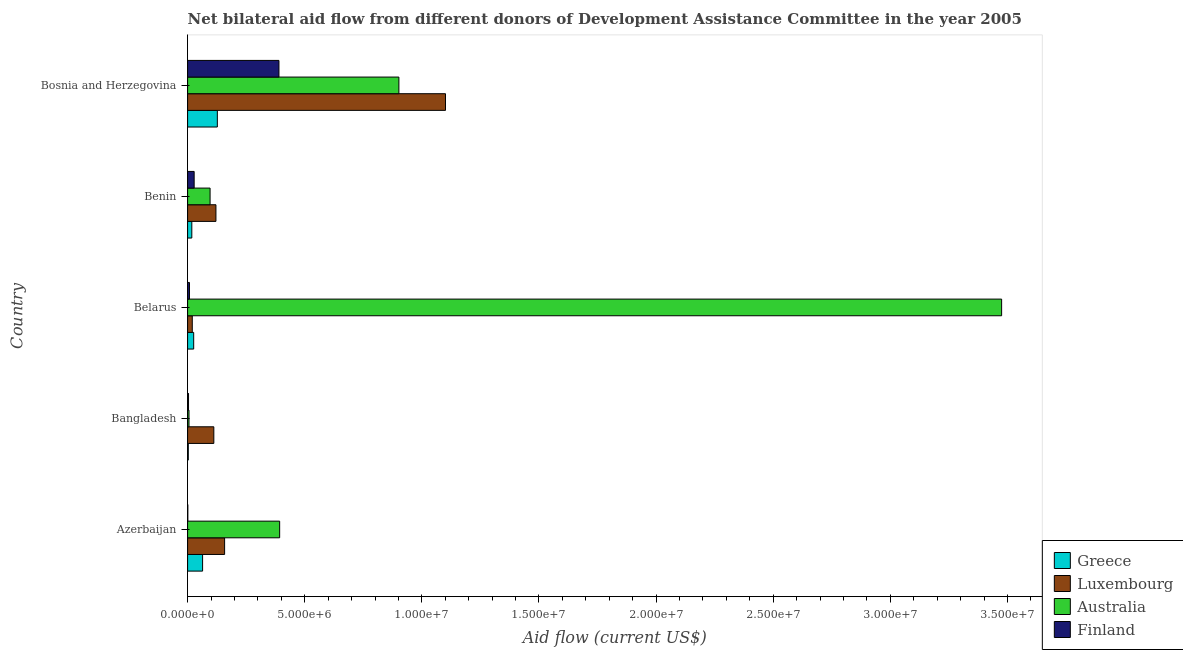How many different coloured bars are there?
Offer a very short reply. 4. How many bars are there on the 4th tick from the top?
Ensure brevity in your answer.  4. How many bars are there on the 1st tick from the bottom?
Your response must be concise. 4. What is the label of the 3rd group of bars from the top?
Ensure brevity in your answer.  Belarus. In how many cases, is the number of bars for a given country not equal to the number of legend labels?
Keep it short and to the point. 0. What is the amount of aid given by luxembourg in Bangladesh?
Ensure brevity in your answer.  1.12e+06. Across all countries, what is the maximum amount of aid given by luxembourg?
Your response must be concise. 1.10e+07. Across all countries, what is the minimum amount of aid given by finland?
Keep it short and to the point. 10000. In which country was the amount of aid given by greece maximum?
Ensure brevity in your answer.  Bosnia and Herzegovina. What is the total amount of aid given by greece in the graph?
Make the answer very short. 2.38e+06. What is the difference between the amount of aid given by luxembourg in Azerbaijan and that in Belarus?
Offer a very short reply. 1.38e+06. What is the difference between the amount of aid given by greece in Bosnia and Herzegovina and the amount of aid given by finland in Azerbaijan?
Offer a terse response. 1.26e+06. What is the average amount of aid given by australia per country?
Provide a short and direct response. 9.74e+06. What is the difference between the amount of aid given by luxembourg and amount of aid given by greece in Benin?
Provide a short and direct response. 1.03e+06. In how many countries, is the amount of aid given by australia greater than 9000000 US$?
Offer a very short reply. 2. What is the ratio of the amount of aid given by luxembourg in Azerbaijan to that in Bosnia and Herzegovina?
Provide a short and direct response. 0.14. Is the difference between the amount of aid given by luxembourg in Azerbaijan and Belarus greater than the difference between the amount of aid given by greece in Azerbaijan and Belarus?
Provide a succinct answer. Yes. What is the difference between the highest and the second highest amount of aid given by australia?
Ensure brevity in your answer.  2.57e+07. What is the difference between the highest and the lowest amount of aid given by finland?
Your answer should be compact. 3.89e+06. In how many countries, is the amount of aid given by finland greater than the average amount of aid given by finland taken over all countries?
Ensure brevity in your answer.  1. Is the sum of the amount of aid given by greece in Belarus and Benin greater than the maximum amount of aid given by luxembourg across all countries?
Your answer should be very brief. No. What does the 2nd bar from the top in Azerbaijan represents?
Make the answer very short. Australia. What does the 3rd bar from the bottom in Bosnia and Herzegovina represents?
Your answer should be very brief. Australia. Is it the case that in every country, the sum of the amount of aid given by greece and amount of aid given by luxembourg is greater than the amount of aid given by australia?
Keep it short and to the point. No. How many bars are there?
Offer a terse response. 20. Are all the bars in the graph horizontal?
Offer a terse response. Yes. Are the values on the major ticks of X-axis written in scientific E-notation?
Give a very brief answer. Yes. Does the graph contain any zero values?
Keep it short and to the point. No. Does the graph contain grids?
Keep it short and to the point. No. Where does the legend appear in the graph?
Your response must be concise. Bottom right. How are the legend labels stacked?
Keep it short and to the point. Vertical. What is the title of the graph?
Offer a very short reply. Net bilateral aid flow from different donors of Development Assistance Committee in the year 2005. What is the label or title of the Y-axis?
Provide a short and direct response. Country. What is the Aid flow (current US$) in Greece in Azerbaijan?
Offer a terse response. 6.40e+05. What is the Aid flow (current US$) of Luxembourg in Azerbaijan?
Your answer should be very brief. 1.58e+06. What is the Aid flow (current US$) of Australia in Azerbaijan?
Provide a succinct answer. 3.93e+06. What is the Aid flow (current US$) of Finland in Azerbaijan?
Keep it short and to the point. 10000. What is the Aid flow (current US$) of Greece in Bangladesh?
Give a very brief answer. 3.00e+04. What is the Aid flow (current US$) of Luxembourg in Bangladesh?
Provide a short and direct response. 1.12e+06. What is the Aid flow (current US$) in Australia in Bangladesh?
Make the answer very short. 6.00e+04. What is the Aid flow (current US$) in Finland in Bangladesh?
Keep it short and to the point. 4.00e+04. What is the Aid flow (current US$) of Greece in Belarus?
Offer a very short reply. 2.60e+05. What is the Aid flow (current US$) of Australia in Belarus?
Make the answer very short. 3.48e+07. What is the Aid flow (current US$) of Finland in Belarus?
Offer a terse response. 8.00e+04. What is the Aid flow (current US$) in Luxembourg in Benin?
Offer a very short reply. 1.21e+06. What is the Aid flow (current US$) of Australia in Benin?
Your answer should be very brief. 9.60e+05. What is the Aid flow (current US$) of Greece in Bosnia and Herzegovina?
Ensure brevity in your answer.  1.27e+06. What is the Aid flow (current US$) of Luxembourg in Bosnia and Herzegovina?
Keep it short and to the point. 1.10e+07. What is the Aid flow (current US$) of Australia in Bosnia and Herzegovina?
Give a very brief answer. 9.02e+06. What is the Aid flow (current US$) in Finland in Bosnia and Herzegovina?
Keep it short and to the point. 3.90e+06. Across all countries, what is the maximum Aid flow (current US$) in Greece?
Your response must be concise. 1.27e+06. Across all countries, what is the maximum Aid flow (current US$) of Luxembourg?
Your response must be concise. 1.10e+07. Across all countries, what is the maximum Aid flow (current US$) in Australia?
Your answer should be compact. 3.48e+07. Across all countries, what is the maximum Aid flow (current US$) in Finland?
Ensure brevity in your answer.  3.90e+06. Across all countries, what is the minimum Aid flow (current US$) in Greece?
Your answer should be very brief. 3.00e+04. Across all countries, what is the minimum Aid flow (current US$) in Australia?
Provide a succinct answer. 6.00e+04. Across all countries, what is the minimum Aid flow (current US$) in Finland?
Provide a short and direct response. 10000. What is the total Aid flow (current US$) of Greece in the graph?
Offer a terse response. 2.38e+06. What is the total Aid flow (current US$) in Luxembourg in the graph?
Provide a succinct answer. 1.51e+07. What is the total Aid flow (current US$) in Australia in the graph?
Provide a short and direct response. 4.87e+07. What is the total Aid flow (current US$) of Finland in the graph?
Provide a succinct answer. 4.31e+06. What is the difference between the Aid flow (current US$) of Greece in Azerbaijan and that in Bangladesh?
Give a very brief answer. 6.10e+05. What is the difference between the Aid flow (current US$) of Australia in Azerbaijan and that in Bangladesh?
Give a very brief answer. 3.87e+06. What is the difference between the Aid flow (current US$) in Greece in Azerbaijan and that in Belarus?
Offer a very short reply. 3.80e+05. What is the difference between the Aid flow (current US$) in Luxembourg in Azerbaijan and that in Belarus?
Provide a short and direct response. 1.38e+06. What is the difference between the Aid flow (current US$) of Australia in Azerbaijan and that in Belarus?
Your answer should be compact. -3.08e+07. What is the difference between the Aid flow (current US$) in Finland in Azerbaijan and that in Belarus?
Offer a very short reply. -7.00e+04. What is the difference between the Aid flow (current US$) in Greece in Azerbaijan and that in Benin?
Make the answer very short. 4.60e+05. What is the difference between the Aid flow (current US$) in Luxembourg in Azerbaijan and that in Benin?
Offer a very short reply. 3.70e+05. What is the difference between the Aid flow (current US$) of Australia in Azerbaijan and that in Benin?
Your answer should be compact. 2.97e+06. What is the difference between the Aid flow (current US$) of Greece in Azerbaijan and that in Bosnia and Herzegovina?
Provide a short and direct response. -6.30e+05. What is the difference between the Aid flow (current US$) of Luxembourg in Azerbaijan and that in Bosnia and Herzegovina?
Your response must be concise. -9.43e+06. What is the difference between the Aid flow (current US$) in Australia in Azerbaijan and that in Bosnia and Herzegovina?
Provide a succinct answer. -5.09e+06. What is the difference between the Aid flow (current US$) of Finland in Azerbaijan and that in Bosnia and Herzegovina?
Provide a succinct answer. -3.89e+06. What is the difference between the Aid flow (current US$) in Greece in Bangladesh and that in Belarus?
Your response must be concise. -2.30e+05. What is the difference between the Aid flow (current US$) in Luxembourg in Bangladesh and that in Belarus?
Give a very brief answer. 9.20e+05. What is the difference between the Aid flow (current US$) in Australia in Bangladesh and that in Belarus?
Your response must be concise. -3.47e+07. What is the difference between the Aid flow (current US$) in Greece in Bangladesh and that in Benin?
Your answer should be very brief. -1.50e+05. What is the difference between the Aid flow (current US$) of Australia in Bangladesh and that in Benin?
Provide a short and direct response. -9.00e+05. What is the difference between the Aid flow (current US$) of Finland in Bangladesh and that in Benin?
Your answer should be very brief. -2.40e+05. What is the difference between the Aid flow (current US$) in Greece in Bangladesh and that in Bosnia and Herzegovina?
Offer a very short reply. -1.24e+06. What is the difference between the Aid flow (current US$) of Luxembourg in Bangladesh and that in Bosnia and Herzegovina?
Offer a terse response. -9.89e+06. What is the difference between the Aid flow (current US$) in Australia in Bangladesh and that in Bosnia and Herzegovina?
Provide a short and direct response. -8.96e+06. What is the difference between the Aid flow (current US$) in Finland in Bangladesh and that in Bosnia and Herzegovina?
Your answer should be very brief. -3.86e+06. What is the difference between the Aid flow (current US$) of Greece in Belarus and that in Benin?
Your response must be concise. 8.00e+04. What is the difference between the Aid flow (current US$) in Luxembourg in Belarus and that in Benin?
Your response must be concise. -1.01e+06. What is the difference between the Aid flow (current US$) in Australia in Belarus and that in Benin?
Offer a terse response. 3.38e+07. What is the difference between the Aid flow (current US$) in Greece in Belarus and that in Bosnia and Herzegovina?
Provide a succinct answer. -1.01e+06. What is the difference between the Aid flow (current US$) of Luxembourg in Belarus and that in Bosnia and Herzegovina?
Provide a short and direct response. -1.08e+07. What is the difference between the Aid flow (current US$) in Australia in Belarus and that in Bosnia and Herzegovina?
Your answer should be very brief. 2.57e+07. What is the difference between the Aid flow (current US$) of Finland in Belarus and that in Bosnia and Herzegovina?
Your answer should be compact. -3.82e+06. What is the difference between the Aid flow (current US$) in Greece in Benin and that in Bosnia and Herzegovina?
Keep it short and to the point. -1.09e+06. What is the difference between the Aid flow (current US$) of Luxembourg in Benin and that in Bosnia and Herzegovina?
Your answer should be very brief. -9.80e+06. What is the difference between the Aid flow (current US$) in Australia in Benin and that in Bosnia and Herzegovina?
Offer a terse response. -8.06e+06. What is the difference between the Aid flow (current US$) of Finland in Benin and that in Bosnia and Herzegovina?
Offer a terse response. -3.62e+06. What is the difference between the Aid flow (current US$) in Greece in Azerbaijan and the Aid flow (current US$) in Luxembourg in Bangladesh?
Offer a terse response. -4.80e+05. What is the difference between the Aid flow (current US$) of Greece in Azerbaijan and the Aid flow (current US$) of Australia in Bangladesh?
Your response must be concise. 5.80e+05. What is the difference between the Aid flow (current US$) in Luxembourg in Azerbaijan and the Aid flow (current US$) in Australia in Bangladesh?
Your answer should be very brief. 1.52e+06. What is the difference between the Aid flow (current US$) in Luxembourg in Azerbaijan and the Aid flow (current US$) in Finland in Bangladesh?
Keep it short and to the point. 1.54e+06. What is the difference between the Aid flow (current US$) in Australia in Azerbaijan and the Aid flow (current US$) in Finland in Bangladesh?
Offer a very short reply. 3.89e+06. What is the difference between the Aid flow (current US$) of Greece in Azerbaijan and the Aid flow (current US$) of Luxembourg in Belarus?
Keep it short and to the point. 4.40e+05. What is the difference between the Aid flow (current US$) of Greece in Azerbaijan and the Aid flow (current US$) of Australia in Belarus?
Offer a terse response. -3.41e+07. What is the difference between the Aid flow (current US$) in Greece in Azerbaijan and the Aid flow (current US$) in Finland in Belarus?
Your answer should be compact. 5.60e+05. What is the difference between the Aid flow (current US$) of Luxembourg in Azerbaijan and the Aid flow (current US$) of Australia in Belarus?
Give a very brief answer. -3.32e+07. What is the difference between the Aid flow (current US$) of Luxembourg in Azerbaijan and the Aid flow (current US$) of Finland in Belarus?
Offer a very short reply. 1.50e+06. What is the difference between the Aid flow (current US$) in Australia in Azerbaijan and the Aid flow (current US$) in Finland in Belarus?
Give a very brief answer. 3.85e+06. What is the difference between the Aid flow (current US$) in Greece in Azerbaijan and the Aid flow (current US$) in Luxembourg in Benin?
Provide a succinct answer. -5.70e+05. What is the difference between the Aid flow (current US$) in Greece in Azerbaijan and the Aid flow (current US$) in Australia in Benin?
Your response must be concise. -3.20e+05. What is the difference between the Aid flow (current US$) in Greece in Azerbaijan and the Aid flow (current US$) in Finland in Benin?
Provide a short and direct response. 3.60e+05. What is the difference between the Aid flow (current US$) of Luxembourg in Azerbaijan and the Aid flow (current US$) of Australia in Benin?
Offer a terse response. 6.20e+05. What is the difference between the Aid flow (current US$) of Luxembourg in Azerbaijan and the Aid flow (current US$) of Finland in Benin?
Make the answer very short. 1.30e+06. What is the difference between the Aid flow (current US$) of Australia in Azerbaijan and the Aid flow (current US$) of Finland in Benin?
Give a very brief answer. 3.65e+06. What is the difference between the Aid flow (current US$) in Greece in Azerbaijan and the Aid flow (current US$) in Luxembourg in Bosnia and Herzegovina?
Provide a succinct answer. -1.04e+07. What is the difference between the Aid flow (current US$) in Greece in Azerbaijan and the Aid flow (current US$) in Australia in Bosnia and Herzegovina?
Your answer should be very brief. -8.38e+06. What is the difference between the Aid flow (current US$) of Greece in Azerbaijan and the Aid flow (current US$) of Finland in Bosnia and Herzegovina?
Your response must be concise. -3.26e+06. What is the difference between the Aid flow (current US$) in Luxembourg in Azerbaijan and the Aid flow (current US$) in Australia in Bosnia and Herzegovina?
Give a very brief answer. -7.44e+06. What is the difference between the Aid flow (current US$) of Luxembourg in Azerbaijan and the Aid flow (current US$) of Finland in Bosnia and Herzegovina?
Ensure brevity in your answer.  -2.32e+06. What is the difference between the Aid flow (current US$) in Australia in Azerbaijan and the Aid flow (current US$) in Finland in Bosnia and Herzegovina?
Make the answer very short. 3.00e+04. What is the difference between the Aid flow (current US$) in Greece in Bangladesh and the Aid flow (current US$) in Australia in Belarus?
Ensure brevity in your answer.  -3.47e+07. What is the difference between the Aid flow (current US$) of Luxembourg in Bangladesh and the Aid flow (current US$) of Australia in Belarus?
Provide a short and direct response. -3.36e+07. What is the difference between the Aid flow (current US$) in Luxembourg in Bangladesh and the Aid flow (current US$) in Finland in Belarus?
Give a very brief answer. 1.04e+06. What is the difference between the Aid flow (current US$) in Greece in Bangladesh and the Aid flow (current US$) in Luxembourg in Benin?
Offer a very short reply. -1.18e+06. What is the difference between the Aid flow (current US$) in Greece in Bangladesh and the Aid flow (current US$) in Australia in Benin?
Provide a succinct answer. -9.30e+05. What is the difference between the Aid flow (current US$) of Luxembourg in Bangladesh and the Aid flow (current US$) of Australia in Benin?
Give a very brief answer. 1.60e+05. What is the difference between the Aid flow (current US$) in Luxembourg in Bangladesh and the Aid flow (current US$) in Finland in Benin?
Provide a short and direct response. 8.40e+05. What is the difference between the Aid flow (current US$) in Australia in Bangladesh and the Aid flow (current US$) in Finland in Benin?
Your answer should be very brief. -2.20e+05. What is the difference between the Aid flow (current US$) in Greece in Bangladesh and the Aid flow (current US$) in Luxembourg in Bosnia and Herzegovina?
Make the answer very short. -1.10e+07. What is the difference between the Aid flow (current US$) of Greece in Bangladesh and the Aid flow (current US$) of Australia in Bosnia and Herzegovina?
Ensure brevity in your answer.  -8.99e+06. What is the difference between the Aid flow (current US$) in Greece in Bangladesh and the Aid flow (current US$) in Finland in Bosnia and Herzegovina?
Offer a very short reply. -3.87e+06. What is the difference between the Aid flow (current US$) of Luxembourg in Bangladesh and the Aid flow (current US$) of Australia in Bosnia and Herzegovina?
Keep it short and to the point. -7.90e+06. What is the difference between the Aid flow (current US$) of Luxembourg in Bangladesh and the Aid flow (current US$) of Finland in Bosnia and Herzegovina?
Ensure brevity in your answer.  -2.78e+06. What is the difference between the Aid flow (current US$) in Australia in Bangladesh and the Aid flow (current US$) in Finland in Bosnia and Herzegovina?
Ensure brevity in your answer.  -3.84e+06. What is the difference between the Aid flow (current US$) of Greece in Belarus and the Aid flow (current US$) of Luxembourg in Benin?
Offer a terse response. -9.50e+05. What is the difference between the Aid flow (current US$) in Greece in Belarus and the Aid flow (current US$) in Australia in Benin?
Keep it short and to the point. -7.00e+05. What is the difference between the Aid flow (current US$) of Greece in Belarus and the Aid flow (current US$) of Finland in Benin?
Offer a very short reply. -2.00e+04. What is the difference between the Aid flow (current US$) in Luxembourg in Belarus and the Aid flow (current US$) in Australia in Benin?
Your response must be concise. -7.60e+05. What is the difference between the Aid flow (current US$) of Australia in Belarus and the Aid flow (current US$) of Finland in Benin?
Offer a very short reply. 3.45e+07. What is the difference between the Aid flow (current US$) of Greece in Belarus and the Aid flow (current US$) of Luxembourg in Bosnia and Herzegovina?
Make the answer very short. -1.08e+07. What is the difference between the Aid flow (current US$) in Greece in Belarus and the Aid flow (current US$) in Australia in Bosnia and Herzegovina?
Make the answer very short. -8.76e+06. What is the difference between the Aid flow (current US$) in Greece in Belarus and the Aid flow (current US$) in Finland in Bosnia and Herzegovina?
Provide a succinct answer. -3.64e+06. What is the difference between the Aid flow (current US$) of Luxembourg in Belarus and the Aid flow (current US$) of Australia in Bosnia and Herzegovina?
Provide a short and direct response. -8.82e+06. What is the difference between the Aid flow (current US$) of Luxembourg in Belarus and the Aid flow (current US$) of Finland in Bosnia and Herzegovina?
Ensure brevity in your answer.  -3.70e+06. What is the difference between the Aid flow (current US$) in Australia in Belarus and the Aid flow (current US$) in Finland in Bosnia and Herzegovina?
Give a very brief answer. 3.08e+07. What is the difference between the Aid flow (current US$) of Greece in Benin and the Aid flow (current US$) of Luxembourg in Bosnia and Herzegovina?
Make the answer very short. -1.08e+07. What is the difference between the Aid flow (current US$) in Greece in Benin and the Aid flow (current US$) in Australia in Bosnia and Herzegovina?
Your answer should be compact. -8.84e+06. What is the difference between the Aid flow (current US$) of Greece in Benin and the Aid flow (current US$) of Finland in Bosnia and Herzegovina?
Provide a succinct answer. -3.72e+06. What is the difference between the Aid flow (current US$) of Luxembourg in Benin and the Aid flow (current US$) of Australia in Bosnia and Herzegovina?
Provide a short and direct response. -7.81e+06. What is the difference between the Aid flow (current US$) in Luxembourg in Benin and the Aid flow (current US$) in Finland in Bosnia and Herzegovina?
Your answer should be very brief. -2.69e+06. What is the difference between the Aid flow (current US$) of Australia in Benin and the Aid flow (current US$) of Finland in Bosnia and Herzegovina?
Your answer should be compact. -2.94e+06. What is the average Aid flow (current US$) in Greece per country?
Provide a short and direct response. 4.76e+05. What is the average Aid flow (current US$) in Luxembourg per country?
Your response must be concise. 3.02e+06. What is the average Aid flow (current US$) of Australia per country?
Provide a short and direct response. 9.74e+06. What is the average Aid flow (current US$) of Finland per country?
Give a very brief answer. 8.62e+05. What is the difference between the Aid flow (current US$) of Greece and Aid flow (current US$) of Luxembourg in Azerbaijan?
Ensure brevity in your answer.  -9.40e+05. What is the difference between the Aid flow (current US$) in Greece and Aid flow (current US$) in Australia in Azerbaijan?
Your response must be concise. -3.29e+06. What is the difference between the Aid flow (current US$) of Greece and Aid flow (current US$) of Finland in Azerbaijan?
Provide a short and direct response. 6.30e+05. What is the difference between the Aid flow (current US$) of Luxembourg and Aid flow (current US$) of Australia in Azerbaijan?
Make the answer very short. -2.35e+06. What is the difference between the Aid flow (current US$) in Luxembourg and Aid flow (current US$) in Finland in Azerbaijan?
Offer a very short reply. 1.57e+06. What is the difference between the Aid flow (current US$) in Australia and Aid flow (current US$) in Finland in Azerbaijan?
Your response must be concise. 3.92e+06. What is the difference between the Aid flow (current US$) of Greece and Aid flow (current US$) of Luxembourg in Bangladesh?
Make the answer very short. -1.09e+06. What is the difference between the Aid flow (current US$) in Greece and Aid flow (current US$) in Australia in Bangladesh?
Offer a terse response. -3.00e+04. What is the difference between the Aid flow (current US$) of Greece and Aid flow (current US$) of Finland in Bangladesh?
Your answer should be compact. -10000. What is the difference between the Aid flow (current US$) of Luxembourg and Aid flow (current US$) of Australia in Bangladesh?
Ensure brevity in your answer.  1.06e+06. What is the difference between the Aid flow (current US$) of Luxembourg and Aid flow (current US$) of Finland in Bangladesh?
Give a very brief answer. 1.08e+06. What is the difference between the Aid flow (current US$) in Australia and Aid flow (current US$) in Finland in Bangladesh?
Make the answer very short. 2.00e+04. What is the difference between the Aid flow (current US$) of Greece and Aid flow (current US$) of Australia in Belarus?
Keep it short and to the point. -3.45e+07. What is the difference between the Aid flow (current US$) of Luxembourg and Aid flow (current US$) of Australia in Belarus?
Make the answer very short. -3.46e+07. What is the difference between the Aid flow (current US$) of Australia and Aid flow (current US$) of Finland in Belarus?
Provide a short and direct response. 3.47e+07. What is the difference between the Aid flow (current US$) in Greece and Aid flow (current US$) in Luxembourg in Benin?
Keep it short and to the point. -1.03e+06. What is the difference between the Aid flow (current US$) of Greece and Aid flow (current US$) of Australia in Benin?
Provide a short and direct response. -7.80e+05. What is the difference between the Aid flow (current US$) in Luxembourg and Aid flow (current US$) in Finland in Benin?
Your response must be concise. 9.30e+05. What is the difference between the Aid flow (current US$) in Australia and Aid flow (current US$) in Finland in Benin?
Offer a very short reply. 6.80e+05. What is the difference between the Aid flow (current US$) in Greece and Aid flow (current US$) in Luxembourg in Bosnia and Herzegovina?
Ensure brevity in your answer.  -9.74e+06. What is the difference between the Aid flow (current US$) of Greece and Aid flow (current US$) of Australia in Bosnia and Herzegovina?
Your answer should be very brief. -7.75e+06. What is the difference between the Aid flow (current US$) of Greece and Aid flow (current US$) of Finland in Bosnia and Herzegovina?
Offer a very short reply. -2.63e+06. What is the difference between the Aid flow (current US$) of Luxembourg and Aid flow (current US$) of Australia in Bosnia and Herzegovina?
Give a very brief answer. 1.99e+06. What is the difference between the Aid flow (current US$) of Luxembourg and Aid flow (current US$) of Finland in Bosnia and Herzegovina?
Your response must be concise. 7.11e+06. What is the difference between the Aid flow (current US$) in Australia and Aid flow (current US$) in Finland in Bosnia and Herzegovina?
Make the answer very short. 5.12e+06. What is the ratio of the Aid flow (current US$) of Greece in Azerbaijan to that in Bangladesh?
Your answer should be compact. 21.33. What is the ratio of the Aid flow (current US$) of Luxembourg in Azerbaijan to that in Bangladesh?
Make the answer very short. 1.41. What is the ratio of the Aid flow (current US$) of Australia in Azerbaijan to that in Bangladesh?
Make the answer very short. 65.5. What is the ratio of the Aid flow (current US$) in Greece in Azerbaijan to that in Belarus?
Your answer should be very brief. 2.46. What is the ratio of the Aid flow (current US$) of Luxembourg in Azerbaijan to that in Belarus?
Offer a terse response. 7.9. What is the ratio of the Aid flow (current US$) in Australia in Azerbaijan to that in Belarus?
Your answer should be compact. 0.11. What is the ratio of the Aid flow (current US$) in Greece in Azerbaijan to that in Benin?
Your response must be concise. 3.56. What is the ratio of the Aid flow (current US$) in Luxembourg in Azerbaijan to that in Benin?
Ensure brevity in your answer.  1.31. What is the ratio of the Aid flow (current US$) of Australia in Azerbaijan to that in Benin?
Provide a succinct answer. 4.09. What is the ratio of the Aid flow (current US$) in Finland in Azerbaijan to that in Benin?
Offer a terse response. 0.04. What is the ratio of the Aid flow (current US$) of Greece in Azerbaijan to that in Bosnia and Herzegovina?
Offer a very short reply. 0.5. What is the ratio of the Aid flow (current US$) of Luxembourg in Azerbaijan to that in Bosnia and Herzegovina?
Your answer should be very brief. 0.14. What is the ratio of the Aid flow (current US$) of Australia in Azerbaijan to that in Bosnia and Herzegovina?
Keep it short and to the point. 0.44. What is the ratio of the Aid flow (current US$) of Finland in Azerbaijan to that in Bosnia and Herzegovina?
Your response must be concise. 0. What is the ratio of the Aid flow (current US$) of Greece in Bangladesh to that in Belarus?
Provide a short and direct response. 0.12. What is the ratio of the Aid flow (current US$) of Australia in Bangladesh to that in Belarus?
Offer a terse response. 0. What is the ratio of the Aid flow (current US$) of Finland in Bangladesh to that in Belarus?
Give a very brief answer. 0.5. What is the ratio of the Aid flow (current US$) in Luxembourg in Bangladesh to that in Benin?
Keep it short and to the point. 0.93. What is the ratio of the Aid flow (current US$) in Australia in Bangladesh to that in Benin?
Provide a succinct answer. 0.06. What is the ratio of the Aid flow (current US$) in Finland in Bangladesh to that in Benin?
Provide a succinct answer. 0.14. What is the ratio of the Aid flow (current US$) of Greece in Bangladesh to that in Bosnia and Herzegovina?
Provide a short and direct response. 0.02. What is the ratio of the Aid flow (current US$) in Luxembourg in Bangladesh to that in Bosnia and Herzegovina?
Give a very brief answer. 0.1. What is the ratio of the Aid flow (current US$) of Australia in Bangladesh to that in Bosnia and Herzegovina?
Offer a terse response. 0.01. What is the ratio of the Aid flow (current US$) in Finland in Bangladesh to that in Bosnia and Herzegovina?
Keep it short and to the point. 0.01. What is the ratio of the Aid flow (current US$) in Greece in Belarus to that in Benin?
Make the answer very short. 1.44. What is the ratio of the Aid flow (current US$) in Luxembourg in Belarus to that in Benin?
Provide a short and direct response. 0.17. What is the ratio of the Aid flow (current US$) of Australia in Belarus to that in Benin?
Keep it short and to the point. 36.2. What is the ratio of the Aid flow (current US$) of Finland in Belarus to that in Benin?
Offer a very short reply. 0.29. What is the ratio of the Aid flow (current US$) in Greece in Belarus to that in Bosnia and Herzegovina?
Make the answer very short. 0.2. What is the ratio of the Aid flow (current US$) in Luxembourg in Belarus to that in Bosnia and Herzegovina?
Offer a terse response. 0.02. What is the ratio of the Aid flow (current US$) of Australia in Belarus to that in Bosnia and Herzegovina?
Provide a short and direct response. 3.85. What is the ratio of the Aid flow (current US$) in Finland in Belarus to that in Bosnia and Herzegovina?
Ensure brevity in your answer.  0.02. What is the ratio of the Aid flow (current US$) of Greece in Benin to that in Bosnia and Herzegovina?
Your answer should be very brief. 0.14. What is the ratio of the Aid flow (current US$) in Luxembourg in Benin to that in Bosnia and Herzegovina?
Give a very brief answer. 0.11. What is the ratio of the Aid flow (current US$) of Australia in Benin to that in Bosnia and Herzegovina?
Offer a terse response. 0.11. What is the ratio of the Aid flow (current US$) in Finland in Benin to that in Bosnia and Herzegovina?
Provide a short and direct response. 0.07. What is the difference between the highest and the second highest Aid flow (current US$) of Greece?
Your answer should be compact. 6.30e+05. What is the difference between the highest and the second highest Aid flow (current US$) in Luxembourg?
Keep it short and to the point. 9.43e+06. What is the difference between the highest and the second highest Aid flow (current US$) in Australia?
Your response must be concise. 2.57e+07. What is the difference between the highest and the second highest Aid flow (current US$) of Finland?
Ensure brevity in your answer.  3.62e+06. What is the difference between the highest and the lowest Aid flow (current US$) of Greece?
Give a very brief answer. 1.24e+06. What is the difference between the highest and the lowest Aid flow (current US$) of Luxembourg?
Provide a short and direct response. 1.08e+07. What is the difference between the highest and the lowest Aid flow (current US$) of Australia?
Provide a succinct answer. 3.47e+07. What is the difference between the highest and the lowest Aid flow (current US$) of Finland?
Offer a terse response. 3.89e+06. 